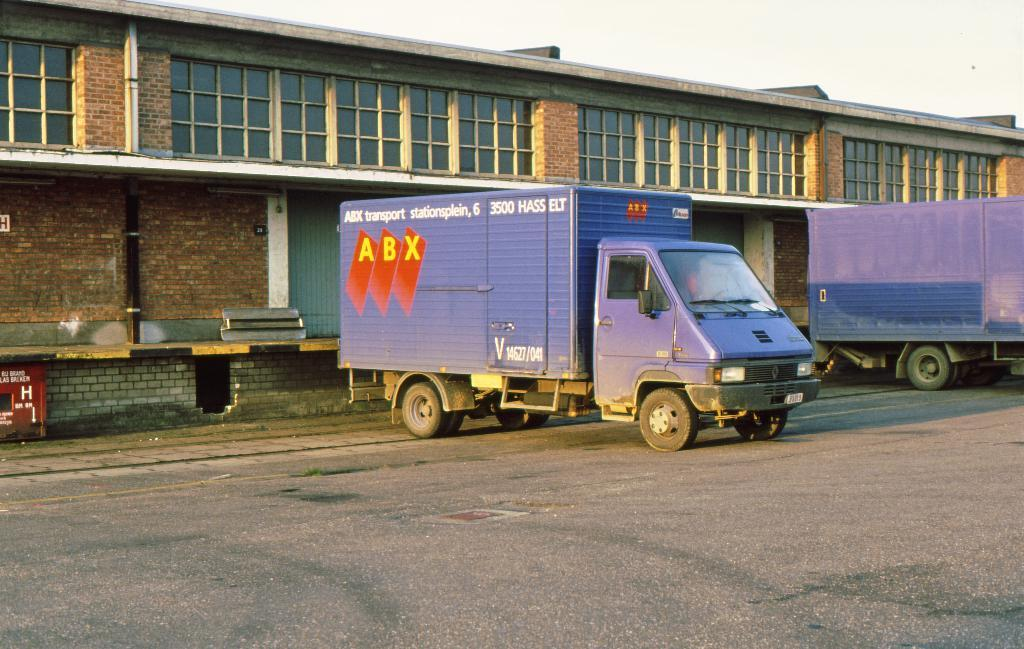What can be seen on the road in the image? There are vehicles on the road in the image. What type of structure is visible in the image? There is a building with windows in the image. What architectural feature is present in the image? There is a wall in the image. What object can be seen in the image that is not a part of the building or wall? There is a pipe in the image. What can be seen in the background of the image? The sky is visible in the background of the image. Can you hear the argument between the vehicles in the image? There is no argument present in the image; it only shows vehicles on the road. Is the person coughing in the image? There is no person present in the image, so it is not possible to determine if someone is coughing. 